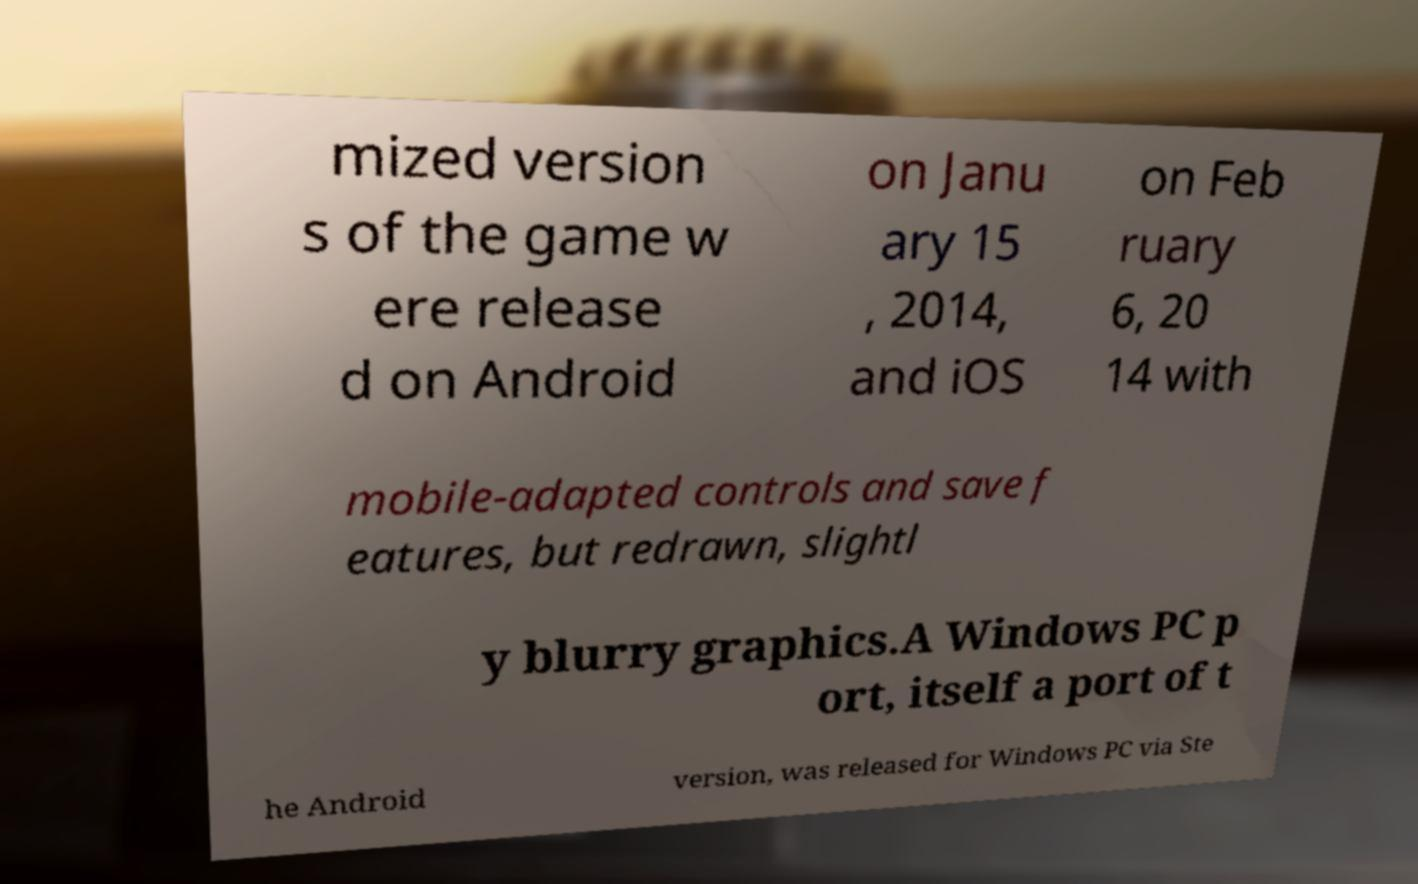Please read and relay the text visible in this image. What does it say? mized version s of the game w ere release d on Android on Janu ary 15 , 2014, and iOS on Feb ruary 6, 20 14 with mobile-adapted controls and save f eatures, but redrawn, slightl y blurry graphics.A Windows PC p ort, itself a port of t he Android version, was released for Windows PC via Ste 